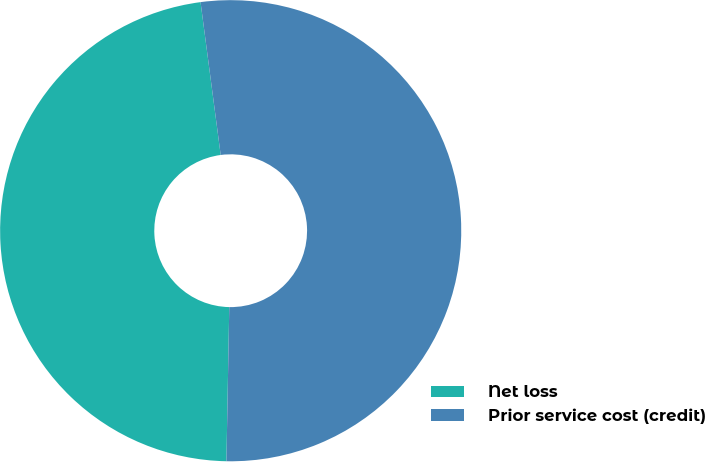Convert chart. <chart><loc_0><loc_0><loc_500><loc_500><pie_chart><fcel>Net loss<fcel>Prior service cost (credit)<nl><fcel>47.62%<fcel>52.38%<nl></chart> 